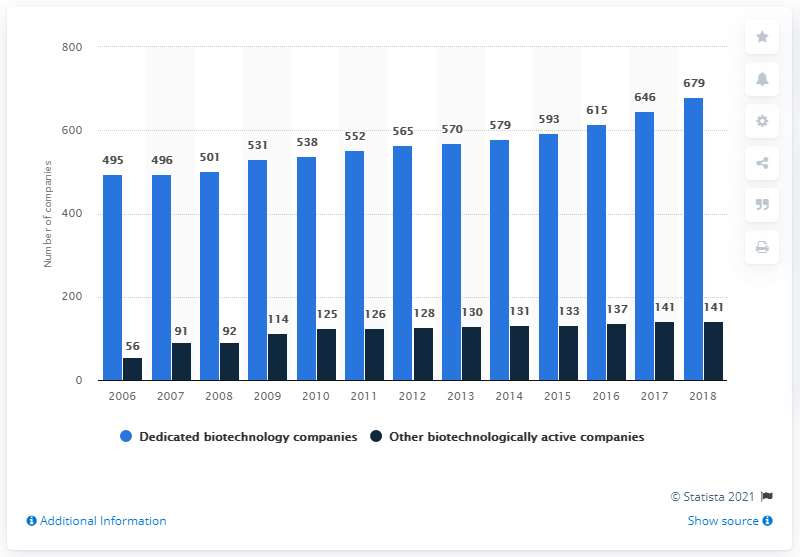What trend in the numbers suggests for the biotechnology industry in Germany in the recent years? The continuous upward trend in both dedicated and other biotechnologically active companies suggests a robust growth in Germany's biotechnology sector, indicating strong ongoing and potential future developments. 